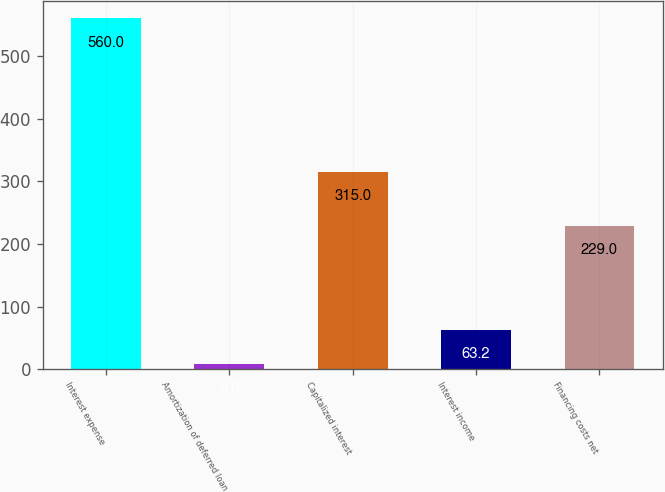Convert chart. <chart><loc_0><loc_0><loc_500><loc_500><bar_chart><fcel>Interest expense<fcel>Amortization of deferred loan<fcel>Capitalized interest<fcel>Interest income<fcel>Financing costs net<nl><fcel>560<fcel>8<fcel>315<fcel>63.2<fcel>229<nl></chart> 